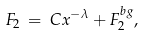Convert formula to latex. <formula><loc_0><loc_0><loc_500><loc_500>F _ { 2 } \, = \, C x ^ { - \lambda } + F _ { 2 } ^ { b g } ,</formula> 